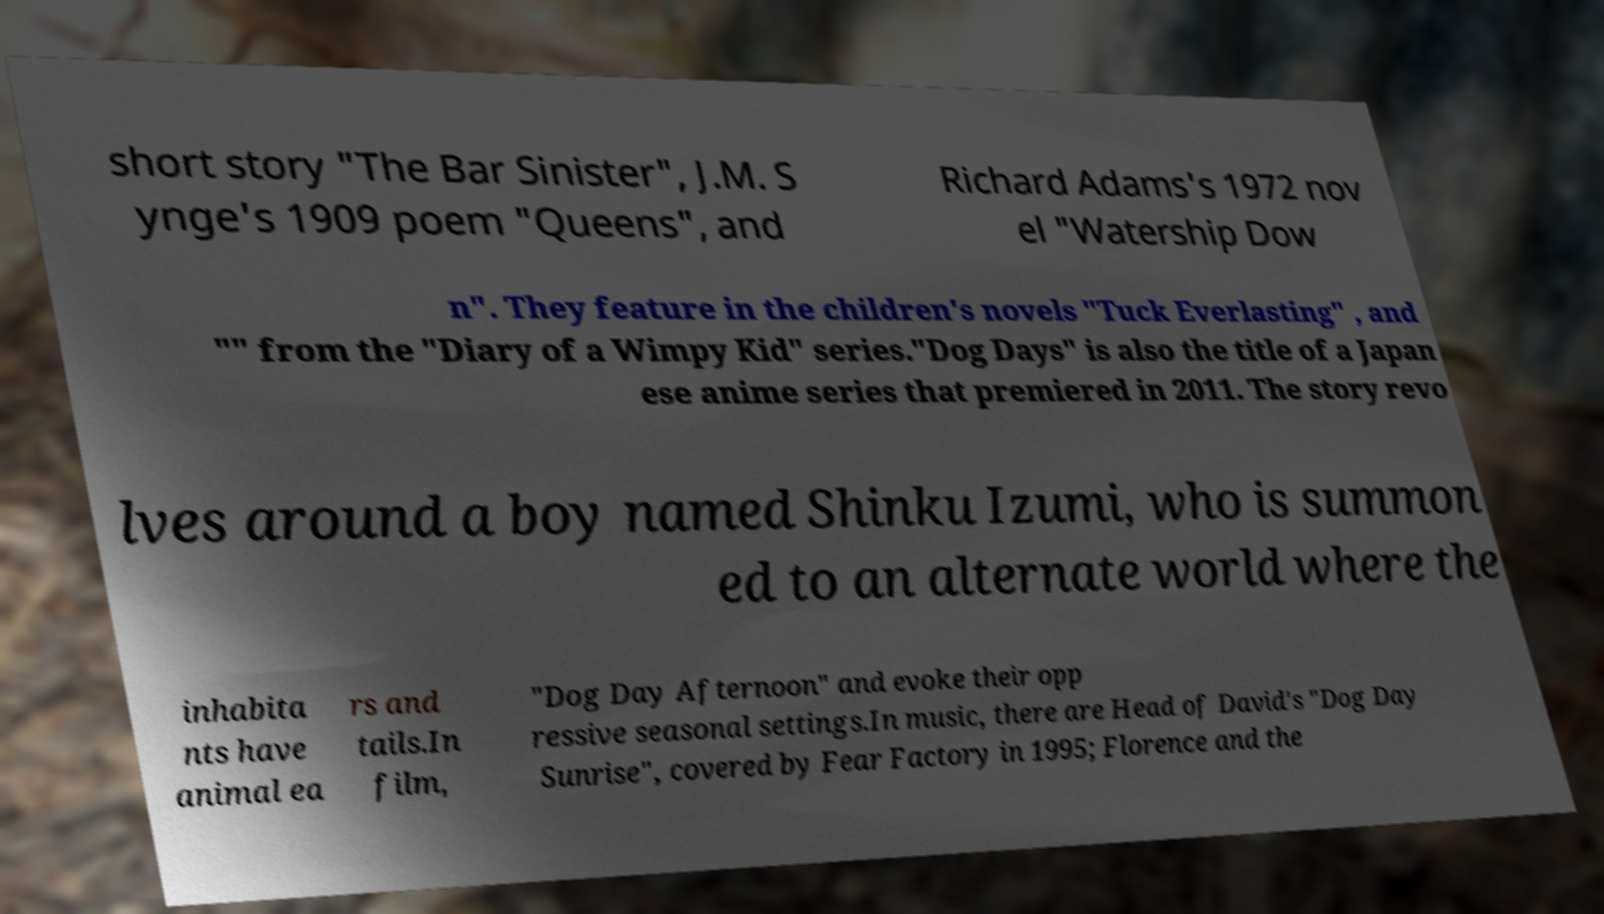Could you assist in decoding the text presented in this image and type it out clearly? short story "The Bar Sinister", J.M. S ynge's 1909 poem "Queens", and Richard Adams's 1972 nov el "Watership Dow n". They feature in the children's novels "Tuck Everlasting" , and "" from the "Diary of a Wimpy Kid" series."Dog Days" is also the title of a Japan ese anime series that premiered in 2011. The story revo lves around a boy named Shinku Izumi, who is summon ed to an alternate world where the inhabita nts have animal ea rs and tails.In film, "Dog Day Afternoon" and evoke their opp ressive seasonal settings.In music, there are Head of David's "Dog Day Sunrise", covered by Fear Factory in 1995; Florence and the 